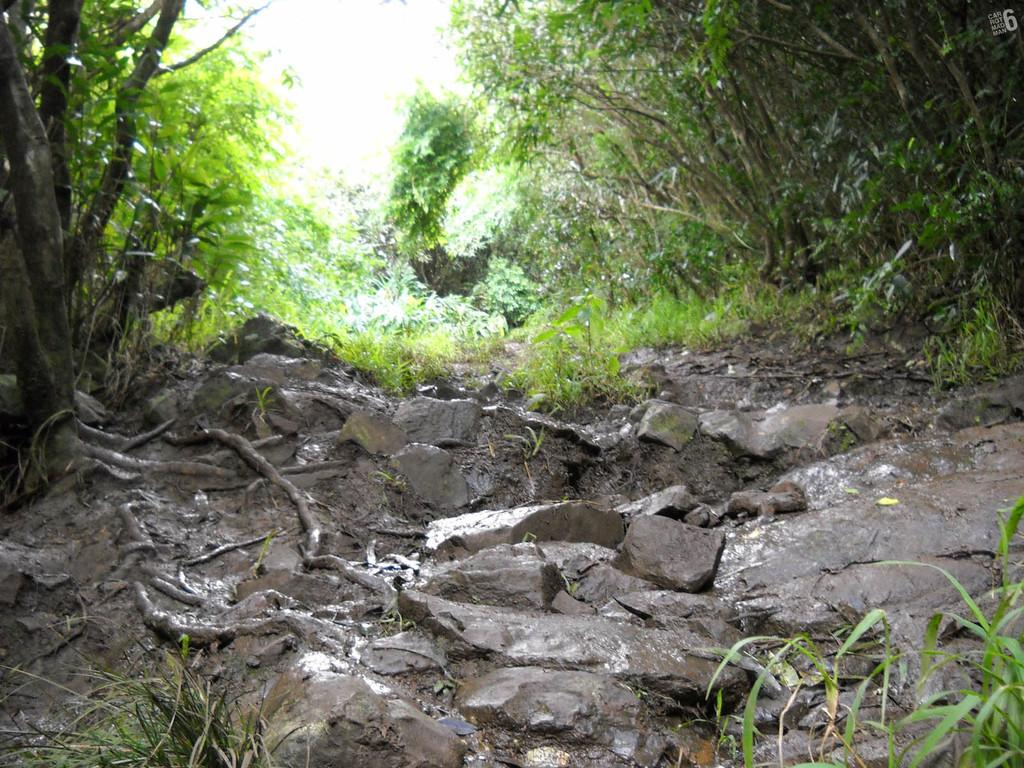What type of vegetation can be seen in the image? There are trees in the image. What other natural elements are present in the image? There are stones and grass visible in the image. What can be seen in the background of the image? The sky is visible in the background of the image. Can you tell me where the zebra is hiding in the image? There is no zebra present in the image. What type of poison is visible in the image? There is no poison present in the image. 